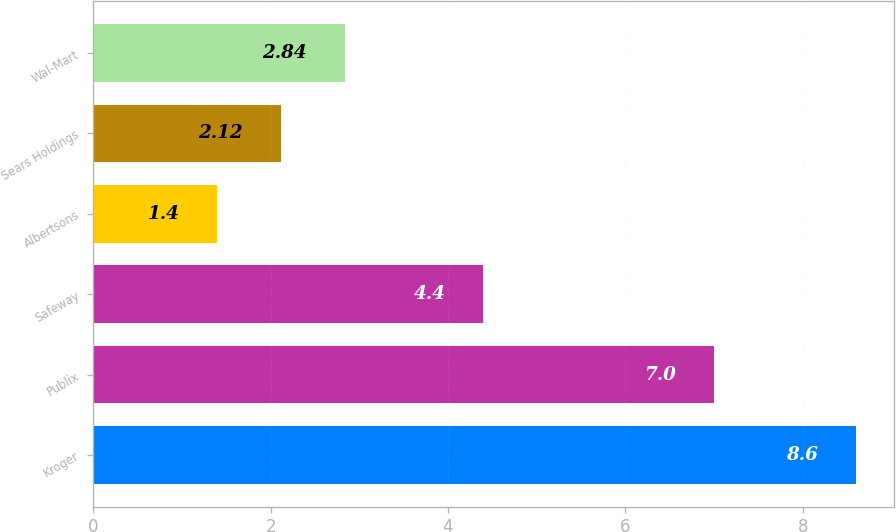Convert chart to OTSL. <chart><loc_0><loc_0><loc_500><loc_500><bar_chart><fcel>Kroger<fcel>Publix<fcel>Safeway<fcel>Albertsons<fcel>Sears Holdings<fcel>Wal-Mart<nl><fcel>8.6<fcel>7<fcel>4.4<fcel>1.4<fcel>2.12<fcel>2.84<nl></chart> 